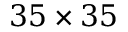Convert formula to latex. <formula><loc_0><loc_0><loc_500><loc_500>3 5 \times 3 5</formula> 